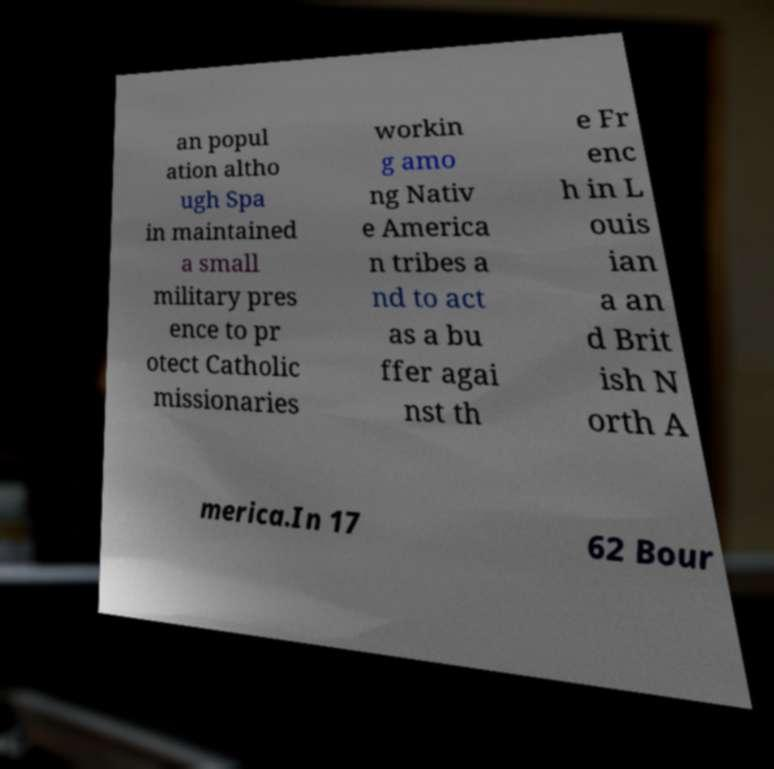Please read and relay the text visible in this image. What does it say? an popul ation altho ugh Spa in maintained a small military pres ence to pr otect Catholic missionaries workin g amo ng Nativ e America n tribes a nd to act as a bu ffer agai nst th e Fr enc h in L ouis ian a an d Brit ish N orth A merica.In 17 62 Bour 